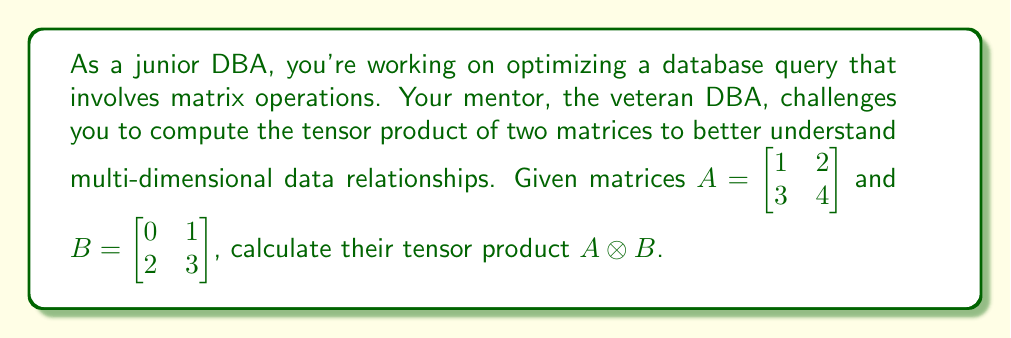Teach me how to tackle this problem. To compute the tensor product of two matrices, we follow these steps:

1) The tensor product $A \otimes B$ of two matrices $A$ (m × n) and $B$ (p × q) results in a matrix of size (mp × nq).

2) Each element of $A$ is multiplied by the entire matrix $B$, and the results are arranged in a block matrix format.

3) For our matrices $A$ (2 × 2) and $B$ (2 × 2), the result will be a 4 × 4 matrix.

4) Let's compute each block:

   For $a_{11} = 1$:
   $$1 \cdot B = \begin{bmatrix} 1 \cdot 0 & 1 \cdot 1 \\ 1 \cdot 2 & 1 \cdot 3 \end{bmatrix} = \begin{bmatrix} 0 & 1 \\ 2 & 3 \end{bmatrix}$$

   For $a_{12} = 2$:
   $$2 \cdot B = \begin{bmatrix} 2 \cdot 0 & 2 \cdot 1 \\ 2 \cdot 2 & 2 \cdot 3 \end{bmatrix} = \begin{bmatrix} 0 & 2 \\ 4 & 6 \end{bmatrix}$$

   For $a_{21} = 3$:
   $$3 \cdot B = \begin{bmatrix} 3 \cdot 0 & 3 \cdot 1 \\ 3 \cdot 2 & 3 \cdot 3 \end{bmatrix} = \begin{bmatrix} 0 & 3 \\ 6 & 9 \end{bmatrix}$$

   For $a_{22} = 4$:
   $$4 \cdot B = \begin{bmatrix} 4 \cdot 0 & 4 \cdot 1 \\ 4 \cdot 2 & 4 \cdot 3 \end{bmatrix} = \begin{bmatrix} 0 & 4 \\ 8 & 12 \end{bmatrix}$$

5) Arranging these blocks in the order they appear in $A$:

$$A \otimes B = \begin{bmatrix}
1 \cdot B & 2 \cdot B \\
3 \cdot B & 4 \cdot B
\end{bmatrix} = \begin{bmatrix}
0 & 1 & 0 & 2 \\
2 & 3 & 4 & 6 \\
0 & 3 & 0 & 4 \\
6 & 9 & 8 & 12
\end{bmatrix}$$
Answer: $$A \otimes B = \begin{bmatrix}
0 & 1 & 0 & 2 \\
2 & 3 & 4 & 6 \\
0 & 3 & 0 & 4 \\
6 & 9 & 8 & 12
\end{bmatrix}$$ 